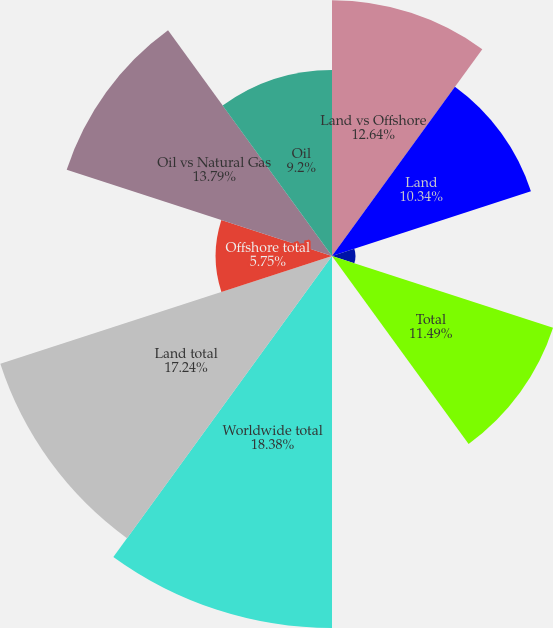Convert chart. <chart><loc_0><loc_0><loc_500><loc_500><pie_chart><fcel>Land vs Offshore<fcel>Land<fcel>Offshore (incl Gulf of Mexico)<fcel>Total<fcel>Offshore<fcel>Worldwide total<fcel>Land total<fcel>Offshore total<fcel>Oil vs Natural Gas<fcel>Oil<nl><fcel>12.64%<fcel>10.34%<fcel>1.16%<fcel>11.49%<fcel>0.01%<fcel>18.39%<fcel>17.24%<fcel>5.75%<fcel>13.79%<fcel>9.2%<nl></chart> 